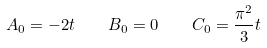Convert formula to latex. <formula><loc_0><loc_0><loc_500><loc_500>A _ { 0 } = - 2 t \quad B _ { 0 } = 0 \quad C _ { 0 } = \frac { \pi ^ { 2 } } { 3 } t</formula> 